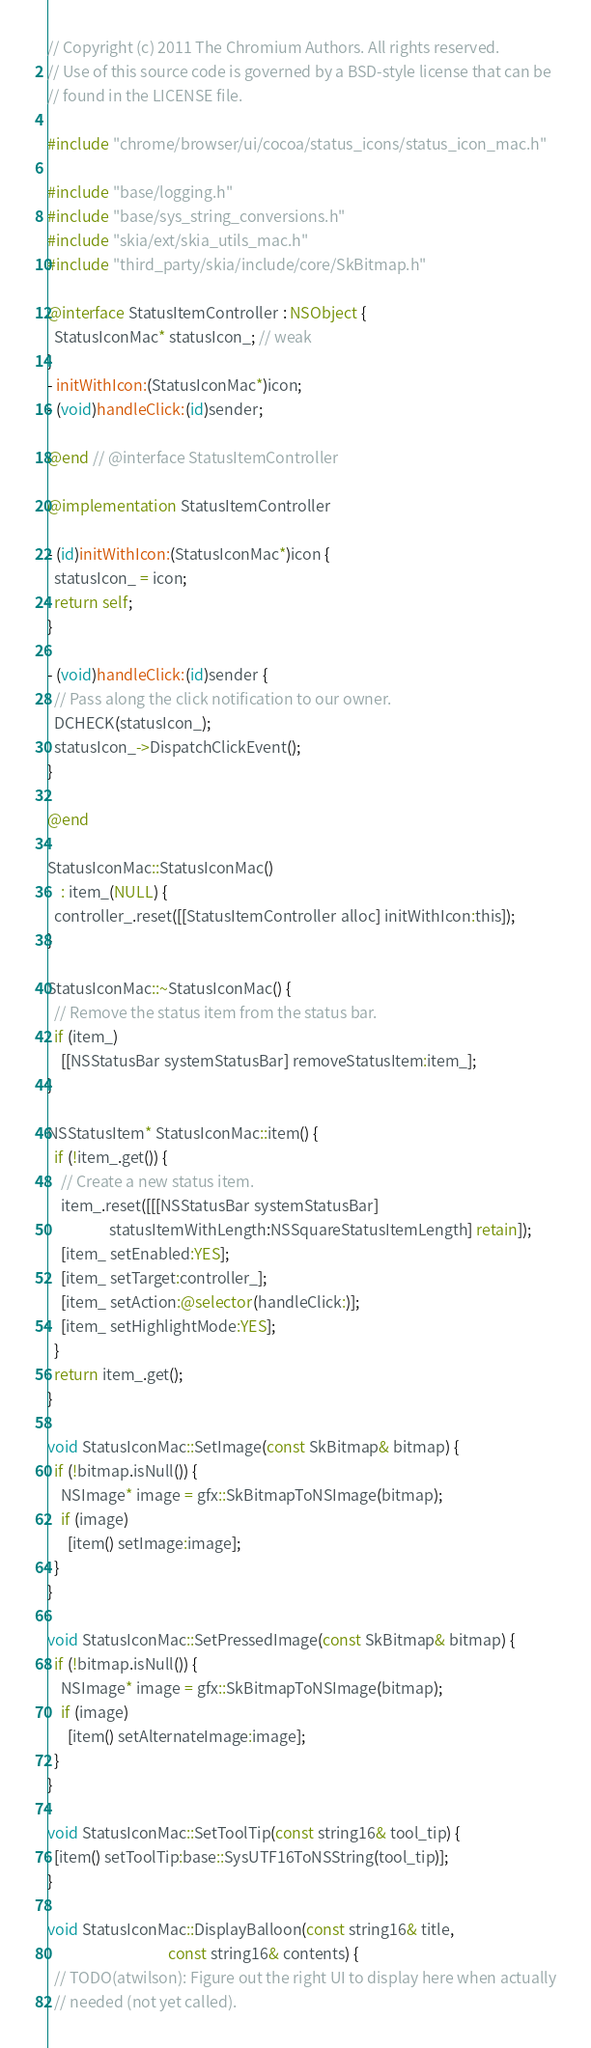Convert code to text. <code><loc_0><loc_0><loc_500><loc_500><_ObjectiveC_>// Copyright (c) 2011 The Chromium Authors. All rights reserved.
// Use of this source code is governed by a BSD-style license that can be
// found in the LICENSE file.

#include "chrome/browser/ui/cocoa/status_icons/status_icon_mac.h"

#include "base/logging.h"
#include "base/sys_string_conversions.h"
#include "skia/ext/skia_utils_mac.h"
#include "third_party/skia/include/core/SkBitmap.h"

@interface StatusItemController : NSObject {
  StatusIconMac* statusIcon_; // weak
}
- initWithIcon:(StatusIconMac*)icon;
- (void)handleClick:(id)sender;

@end // @interface StatusItemController

@implementation StatusItemController

- (id)initWithIcon:(StatusIconMac*)icon {
  statusIcon_ = icon;
  return self;
}

- (void)handleClick:(id)sender {
  // Pass along the click notification to our owner.
  DCHECK(statusIcon_);
  statusIcon_->DispatchClickEvent();
}

@end

StatusIconMac::StatusIconMac()
    : item_(NULL) {
  controller_.reset([[StatusItemController alloc] initWithIcon:this]);
}

StatusIconMac::~StatusIconMac() {
  // Remove the status item from the status bar.
  if (item_)
    [[NSStatusBar systemStatusBar] removeStatusItem:item_];
}

NSStatusItem* StatusIconMac::item() {
  if (!item_.get()) {
    // Create a new status item.
    item_.reset([[[NSStatusBar systemStatusBar]
                  statusItemWithLength:NSSquareStatusItemLength] retain]);
    [item_ setEnabled:YES];
    [item_ setTarget:controller_];
    [item_ setAction:@selector(handleClick:)];
    [item_ setHighlightMode:YES];
  }
  return item_.get();
}

void StatusIconMac::SetImage(const SkBitmap& bitmap) {
  if (!bitmap.isNull()) {
    NSImage* image = gfx::SkBitmapToNSImage(bitmap);
    if (image)
      [item() setImage:image];
  }
}

void StatusIconMac::SetPressedImage(const SkBitmap& bitmap) {
  if (!bitmap.isNull()) {
    NSImage* image = gfx::SkBitmapToNSImage(bitmap);
    if (image)
      [item() setAlternateImage:image];
  }
}

void StatusIconMac::SetToolTip(const string16& tool_tip) {
  [item() setToolTip:base::SysUTF16ToNSString(tool_tip)];
}

void StatusIconMac::DisplayBalloon(const string16& title,
                                   const string16& contents) {
  // TODO(atwilson): Figure out the right UI to display here when actually
  // needed (not yet called).</code> 